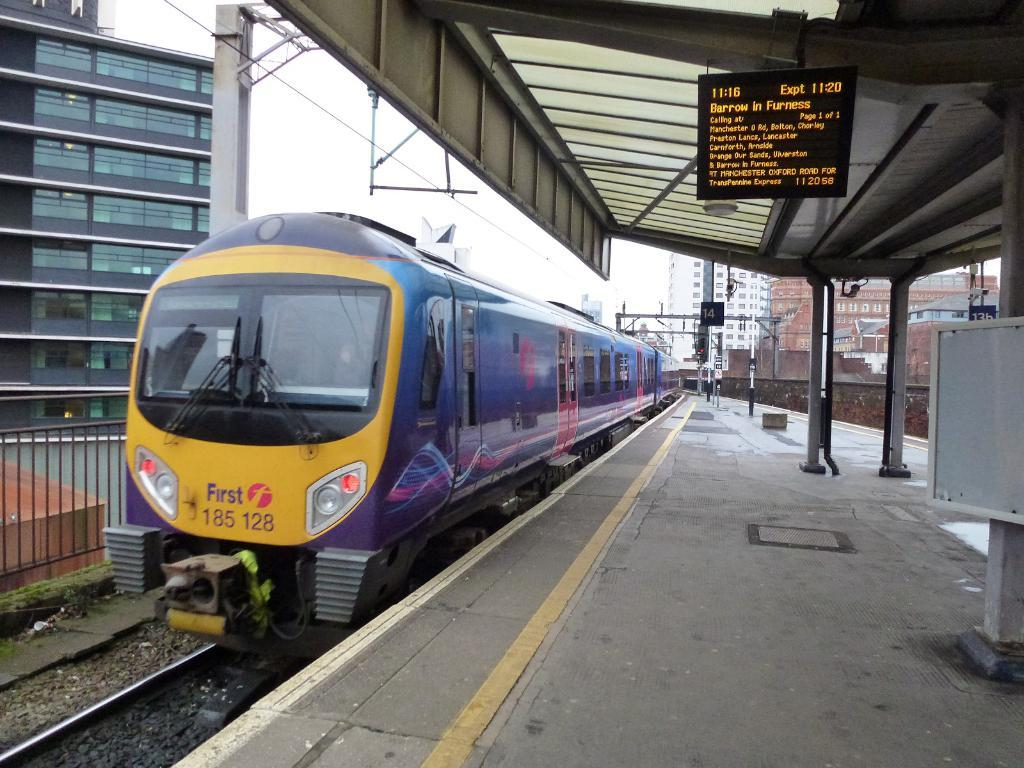<image>
Create a compact narrative representing the image presented. A passenger train waits at the Barrow in Furness train station platform. 